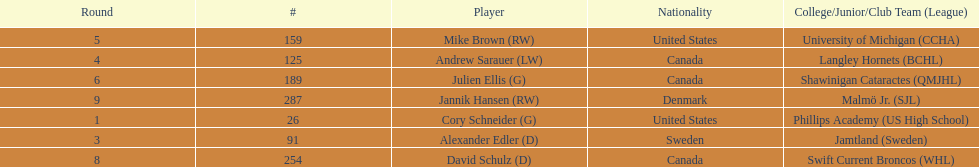Which player has canadian nationality and attended langley hornets? Andrew Sarauer (LW). 